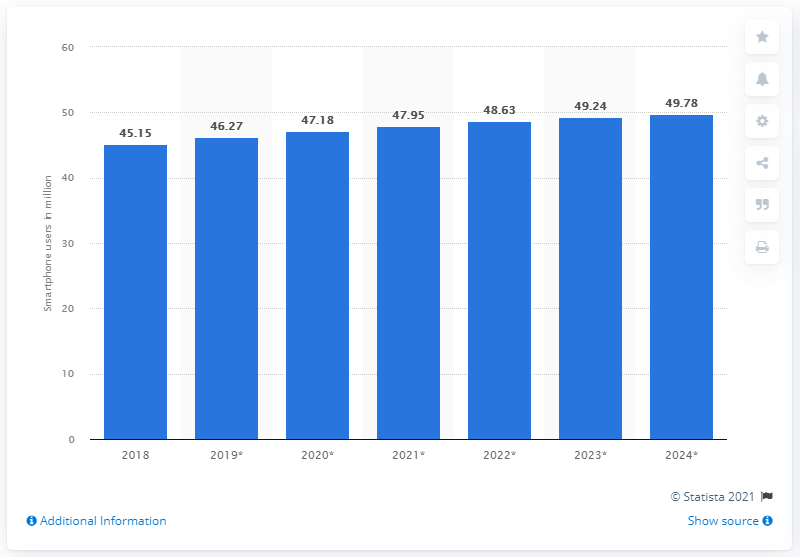Specify some key components in this picture. According to projections, the number of smartphone users in France is expected to increase from 47.18 million in 2018 to 52.59 million in 2024. In 2020, it is estimated that there will be approximately 47.18 million smartphone users in France. 